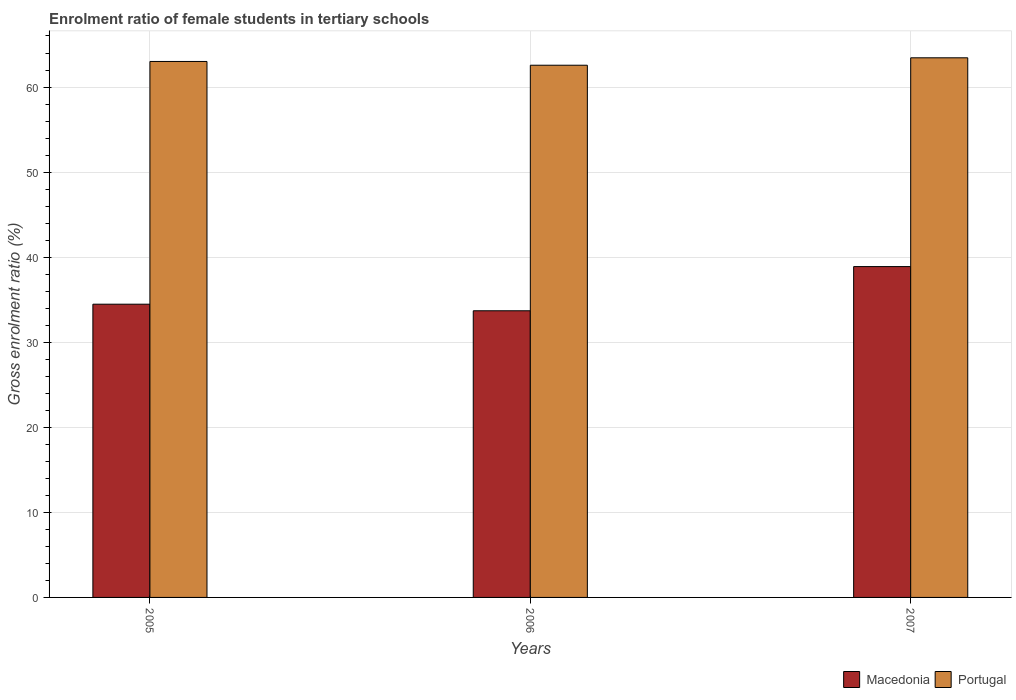Are the number of bars per tick equal to the number of legend labels?
Your answer should be very brief. Yes. Are the number of bars on each tick of the X-axis equal?
Your answer should be compact. Yes. How many bars are there on the 3rd tick from the right?
Ensure brevity in your answer.  2. What is the label of the 3rd group of bars from the left?
Provide a succinct answer. 2007. What is the enrolment ratio of female students in tertiary schools in Macedonia in 2005?
Ensure brevity in your answer.  34.47. Across all years, what is the maximum enrolment ratio of female students in tertiary schools in Portugal?
Provide a short and direct response. 63.44. Across all years, what is the minimum enrolment ratio of female students in tertiary schools in Macedonia?
Offer a terse response. 33.7. In which year was the enrolment ratio of female students in tertiary schools in Macedonia minimum?
Your answer should be very brief. 2006. What is the total enrolment ratio of female students in tertiary schools in Macedonia in the graph?
Offer a terse response. 107.06. What is the difference between the enrolment ratio of female students in tertiary schools in Macedonia in 2006 and that in 2007?
Your response must be concise. -5.19. What is the difference between the enrolment ratio of female students in tertiary schools in Macedonia in 2007 and the enrolment ratio of female students in tertiary schools in Portugal in 2006?
Provide a short and direct response. -23.67. What is the average enrolment ratio of female students in tertiary schools in Macedonia per year?
Make the answer very short. 35.69. In the year 2006, what is the difference between the enrolment ratio of female students in tertiary schools in Macedonia and enrolment ratio of female students in tertiary schools in Portugal?
Provide a short and direct response. -28.86. In how many years, is the enrolment ratio of female students in tertiary schools in Macedonia greater than 24 %?
Keep it short and to the point. 3. What is the ratio of the enrolment ratio of female students in tertiary schools in Macedonia in 2006 to that in 2007?
Keep it short and to the point. 0.87. Is the difference between the enrolment ratio of female students in tertiary schools in Macedonia in 2006 and 2007 greater than the difference between the enrolment ratio of female students in tertiary schools in Portugal in 2006 and 2007?
Your answer should be compact. No. What is the difference between the highest and the second highest enrolment ratio of female students in tertiary schools in Portugal?
Offer a very short reply. 0.43. What is the difference between the highest and the lowest enrolment ratio of female students in tertiary schools in Macedonia?
Provide a succinct answer. 5.19. In how many years, is the enrolment ratio of female students in tertiary schools in Macedonia greater than the average enrolment ratio of female students in tertiary schools in Macedonia taken over all years?
Your response must be concise. 1. Is the sum of the enrolment ratio of female students in tertiary schools in Macedonia in 2005 and 2007 greater than the maximum enrolment ratio of female students in tertiary schools in Portugal across all years?
Provide a short and direct response. Yes. What does the 1st bar from the left in 2006 represents?
Provide a succinct answer. Macedonia. What does the 1st bar from the right in 2007 represents?
Your answer should be very brief. Portugal. How many bars are there?
Provide a short and direct response. 6. What is the difference between two consecutive major ticks on the Y-axis?
Your answer should be compact. 10. Does the graph contain any zero values?
Provide a succinct answer. No. Does the graph contain grids?
Make the answer very short. Yes. Where does the legend appear in the graph?
Offer a terse response. Bottom right. What is the title of the graph?
Offer a very short reply. Enrolment ratio of female students in tertiary schools. Does "Djibouti" appear as one of the legend labels in the graph?
Make the answer very short. No. What is the label or title of the Y-axis?
Your response must be concise. Gross enrolment ratio (%). What is the Gross enrolment ratio (%) of Macedonia in 2005?
Offer a terse response. 34.47. What is the Gross enrolment ratio (%) in Portugal in 2005?
Your answer should be very brief. 63.01. What is the Gross enrolment ratio (%) of Macedonia in 2006?
Your answer should be very brief. 33.7. What is the Gross enrolment ratio (%) of Portugal in 2006?
Provide a short and direct response. 62.56. What is the Gross enrolment ratio (%) in Macedonia in 2007?
Give a very brief answer. 38.89. What is the Gross enrolment ratio (%) in Portugal in 2007?
Offer a terse response. 63.44. Across all years, what is the maximum Gross enrolment ratio (%) of Macedonia?
Make the answer very short. 38.89. Across all years, what is the maximum Gross enrolment ratio (%) in Portugal?
Your response must be concise. 63.44. Across all years, what is the minimum Gross enrolment ratio (%) of Macedonia?
Your response must be concise. 33.7. Across all years, what is the minimum Gross enrolment ratio (%) in Portugal?
Offer a very short reply. 62.56. What is the total Gross enrolment ratio (%) of Macedonia in the graph?
Provide a short and direct response. 107.06. What is the total Gross enrolment ratio (%) of Portugal in the graph?
Provide a short and direct response. 189.01. What is the difference between the Gross enrolment ratio (%) of Macedonia in 2005 and that in 2006?
Make the answer very short. 0.77. What is the difference between the Gross enrolment ratio (%) of Portugal in 2005 and that in 2006?
Your response must be concise. 0.44. What is the difference between the Gross enrolment ratio (%) in Macedonia in 2005 and that in 2007?
Give a very brief answer. -4.42. What is the difference between the Gross enrolment ratio (%) in Portugal in 2005 and that in 2007?
Make the answer very short. -0.43. What is the difference between the Gross enrolment ratio (%) of Macedonia in 2006 and that in 2007?
Give a very brief answer. -5.19. What is the difference between the Gross enrolment ratio (%) in Portugal in 2006 and that in 2007?
Keep it short and to the point. -0.87. What is the difference between the Gross enrolment ratio (%) of Macedonia in 2005 and the Gross enrolment ratio (%) of Portugal in 2006?
Your answer should be compact. -28.09. What is the difference between the Gross enrolment ratio (%) in Macedonia in 2005 and the Gross enrolment ratio (%) in Portugal in 2007?
Ensure brevity in your answer.  -28.96. What is the difference between the Gross enrolment ratio (%) of Macedonia in 2006 and the Gross enrolment ratio (%) of Portugal in 2007?
Give a very brief answer. -29.74. What is the average Gross enrolment ratio (%) in Macedonia per year?
Make the answer very short. 35.69. What is the average Gross enrolment ratio (%) of Portugal per year?
Give a very brief answer. 63. In the year 2005, what is the difference between the Gross enrolment ratio (%) of Macedonia and Gross enrolment ratio (%) of Portugal?
Your answer should be compact. -28.53. In the year 2006, what is the difference between the Gross enrolment ratio (%) of Macedonia and Gross enrolment ratio (%) of Portugal?
Offer a terse response. -28.86. In the year 2007, what is the difference between the Gross enrolment ratio (%) of Macedonia and Gross enrolment ratio (%) of Portugal?
Keep it short and to the point. -24.54. What is the ratio of the Gross enrolment ratio (%) of Portugal in 2005 to that in 2006?
Ensure brevity in your answer.  1.01. What is the ratio of the Gross enrolment ratio (%) in Macedonia in 2005 to that in 2007?
Keep it short and to the point. 0.89. What is the ratio of the Gross enrolment ratio (%) of Portugal in 2005 to that in 2007?
Your answer should be compact. 0.99. What is the ratio of the Gross enrolment ratio (%) of Macedonia in 2006 to that in 2007?
Your answer should be compact. 0.87. What is the ratio of the Gross enrolment ratio (%) in Portugal in 2006 to that in 2007?
Offer a terse response. 0.99. What is the difference between the highest and the second highest Gross enrolment ratio (%) of Macedonia?
Keep it short and to the point. 4.42. What is the difference between the highest and the second highest Gross enrolment ratio (%) of Portugal?
Your answer should be very brief. 0.43. What is the difference between the highest and the lowest Gross enrolment ratio (%) of Macedonia?
Keep it short and to the point. 5.19. What is the difference between the highest and the lowest Gross enrolment ratio (%) in Portugal?
Your response must be concise. 0.87. 